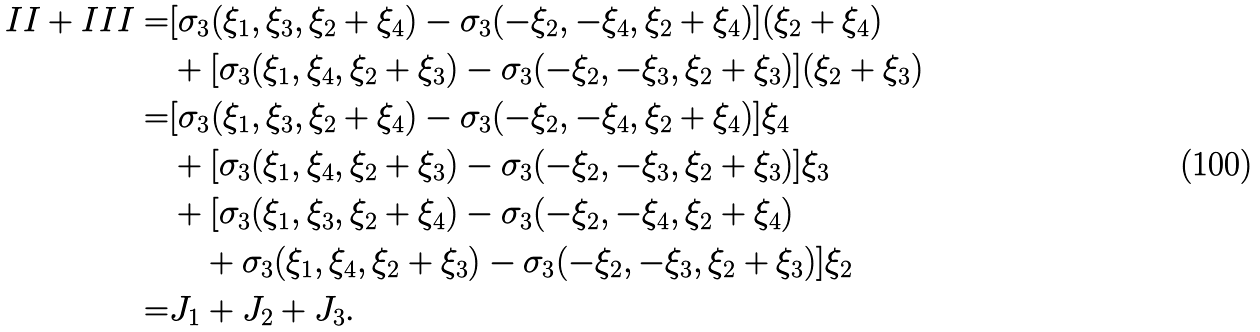Convert formula to latex. <formula><loc_0><loc_0><loc_500><loc_500>I I + I I I = & [ \sigma _ { 3 } ( \xi _ { 1 } , \xi _ { 3 } , \xi _ { 2 } + \xi _ { 4 } ) - \sigma _ { 3 } ( - \xi _ { 2 } , - \xi _ { 4 } , \xi _ { 2 } + \xi _ { 4 } ) ] ( \xi _ { 2 } + \xi _ { 4 } ) \\ & + [ \sigma _ { 3 } ( \xi _ { 1 } , \xi _ { 4 } , \xi _ { 2 } + \xi _ { 3 } ) - \sigma _ { 3 } ( - \xi _ { 2 } , - \xi _ { 3 } , \xi _ { 2 } + \xi _ { 3 } ) ] ( \xi _ { 2 } + \xi _ { 3 } ) \\ = & [ \sigma _ { 3 } ( \xi _ { 1 } , \xi _ { 3 } , \xi _ { 2 } + \xi _ { 4 } ) - \sigma _ { 3 } ( - \xi _ { 2 } , - \xi _ { 4 } , \xi _ { 2 } + \xi _ { 4 } ) ] \xi _ { 4 } \\ & + [ \sigma _ { 3 } ( \xi _ { 1 } , \xi _ { 4 } , \xi _ { 2 } + \xi _ { 3 } ) - \sigma _ { 3 } ( - \xi _ { 2 } , - \xi _ { 3 } , \xi _ { 2 } + \xi _ { 3 } ) ] \xi _ { 3 } \\ & + [ \sigma _ { 3 } ( \xi _ { 1 } , \xi _ { 3 } , \xi _ { 2 } + \xi _ { 4 } ) - \sigma _ { 3 } ( - \xi _ { 2 } , - \xi _ { 4 } , \xi _ { 2 } + \xi _ { 4 } ) \\ & \quad + \sigma _ { 3 } ( \xi _ { 1 } , \xi _ { 4 } , \xi _ { 2 } + \xi _ { 3 } ) - \sigma _ { 3 } ( - \xi _ { 2 } , - \xi _ { 3 } , \xi _ { 2 } + \xi _ { 3 } ) ] \xi _ { 2 } \\ = & J _ { 1 } + J _ { 2 } + J _ { 3 } .</formula> 